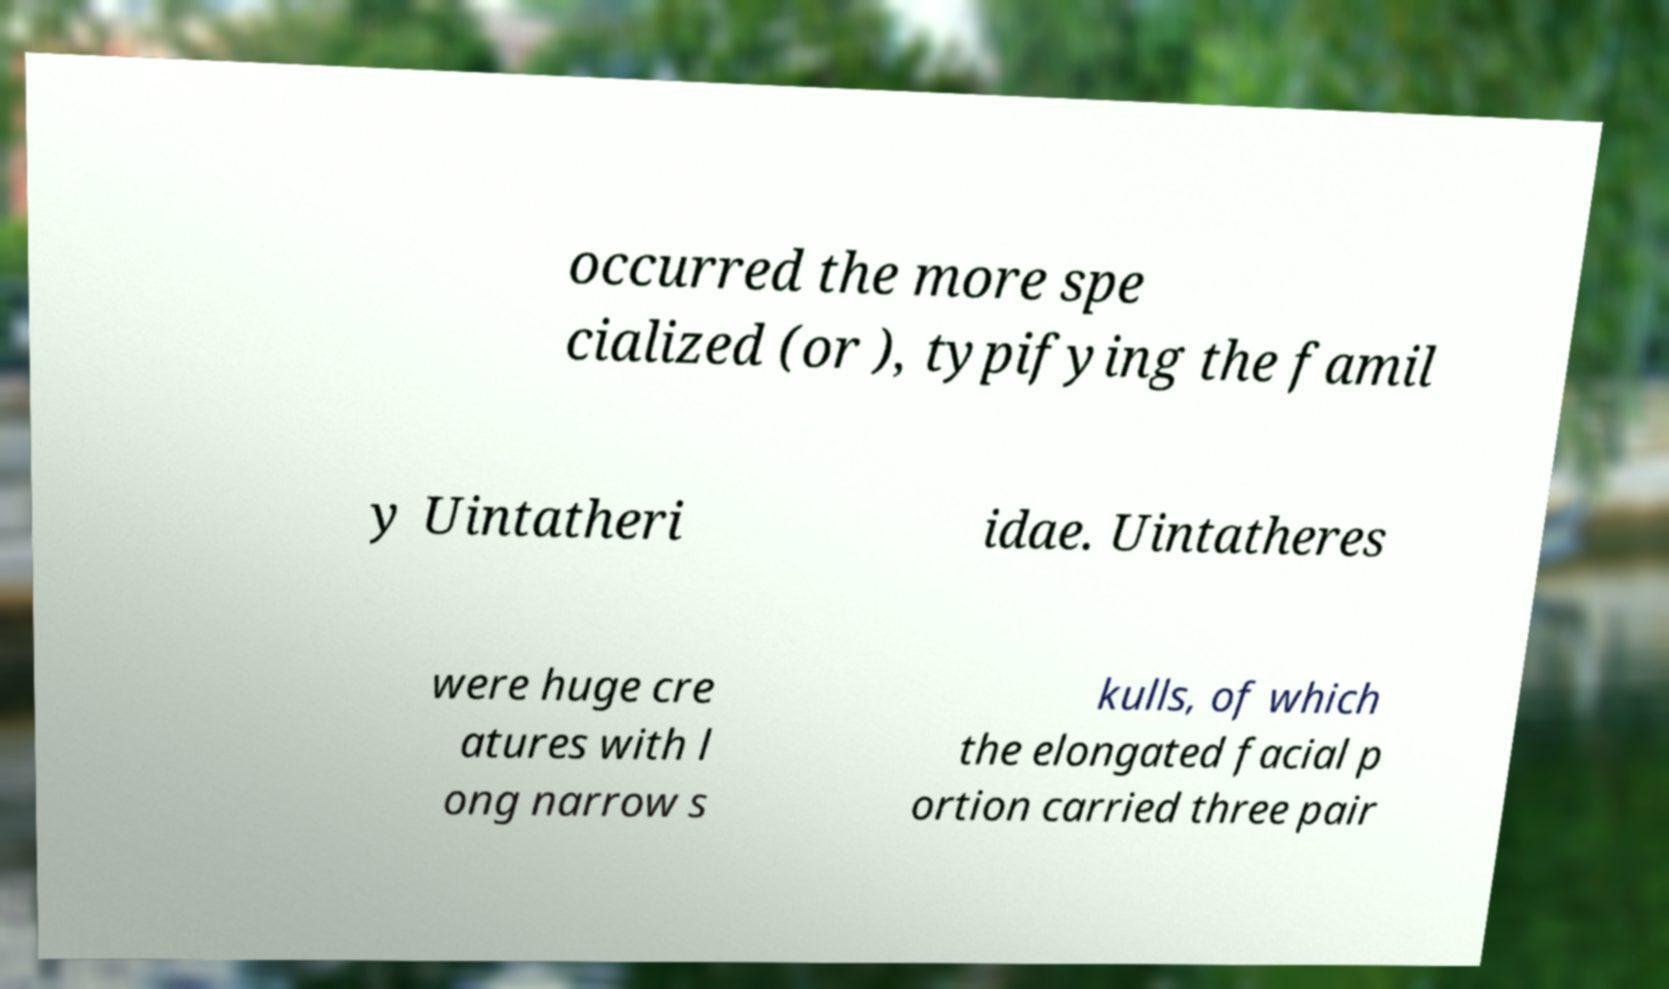Please identify and transcribe the text found in this image. occurred the more spe cialized (or ), typifying the famil y Uintatheri idae. Uintatheres were huge cre atures with l ong narrow s kulls, of which the elongated facial p ortion carried three pair 